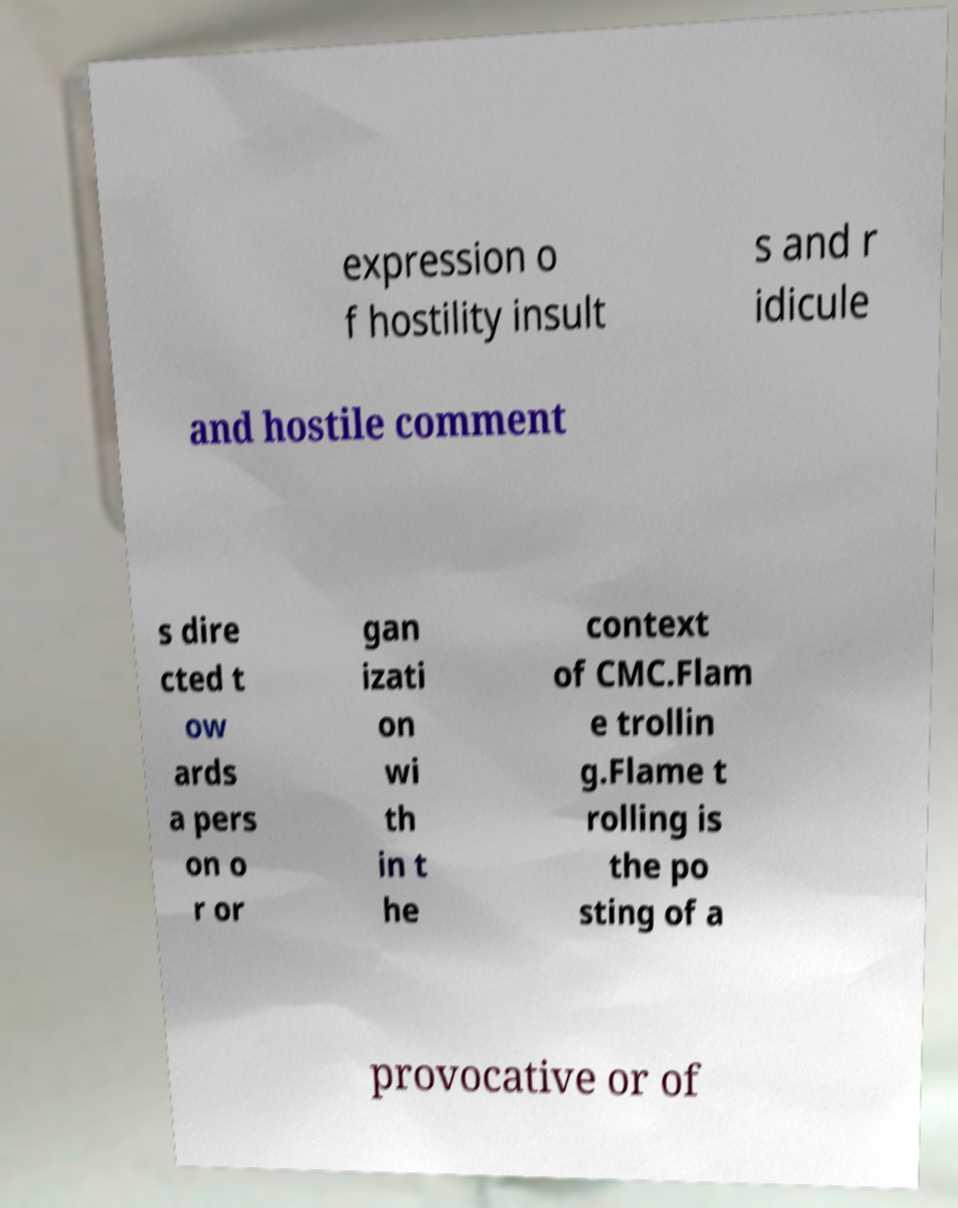Please identify and transcribe the text found in this image. expression o f hostility insult s and r idicule and hostile comment s dire cted t ow ards a pers on o r or gan izati on wi th in t he context of CMC.Flam e trollin g.Flame t rolling is the po sting of a provocative or of 